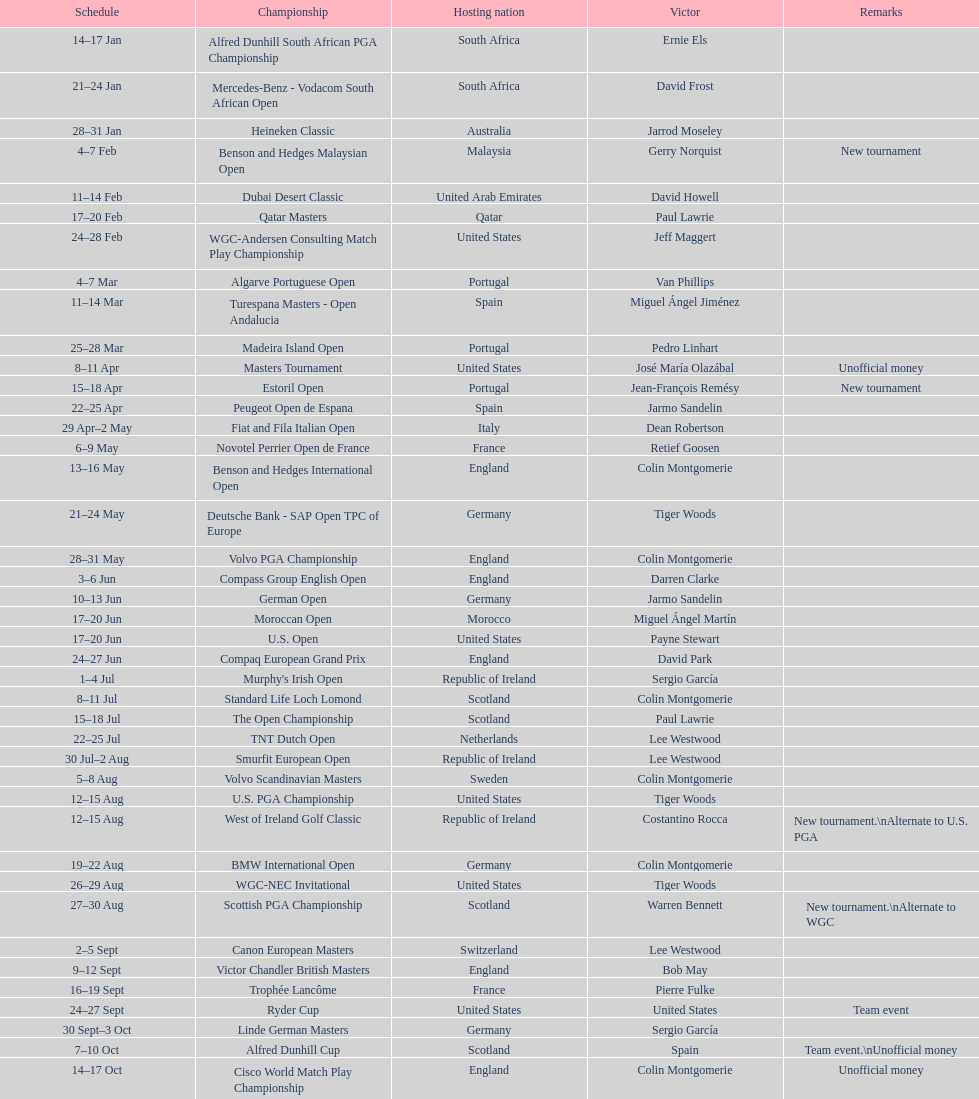Which country was mentioned when a new tournament was first introduced? Malaysia. 